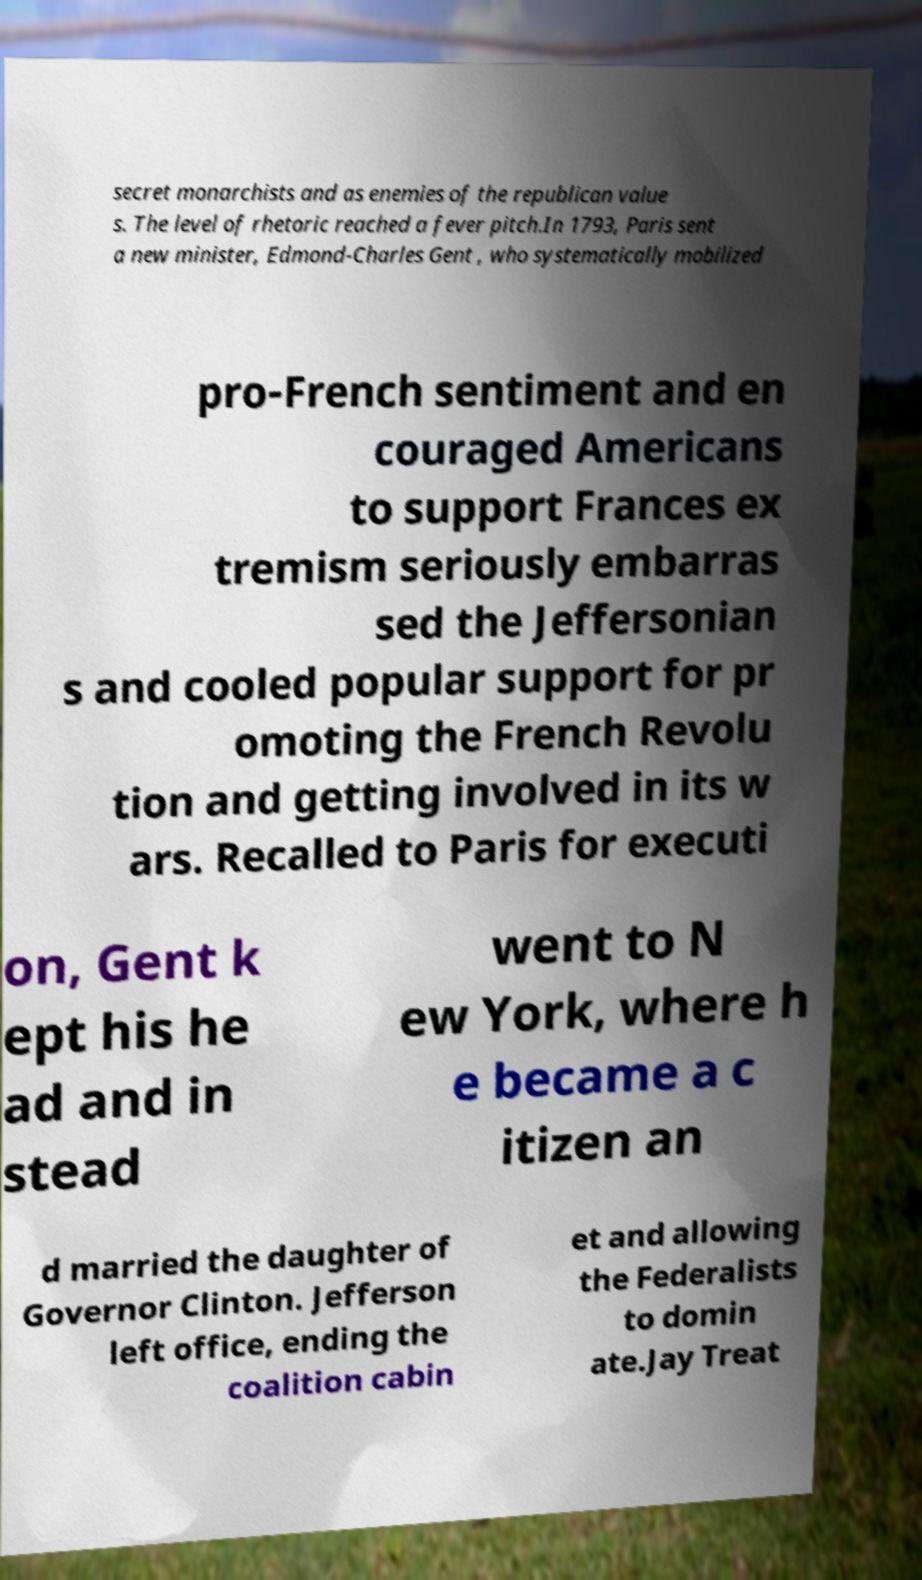There's text embedded in this image that I need extracted. Can you transcribe it verbatim? secret monarchists and as enemies of the republican value s. The level of rhetoric reached a fever pitch.In 1793, Paris sent a new minister, Edmond-Charles Gent , who systematically mobilized pro-French sentiment and en couraged Americans to support Frances ex tremism seriously embarras sed the Jeffersonian s and cooled popular support for pr omoting the French Revolu tion and getting involved in its w ars. Recalled to Paris for executi on, Gent k ept his he ad and in stead went to N ew York, where h e became a c itizen an d married the daughter of Governor Clinton. Jefferson left office, ending the coalition cabin et and allowing the Federalists to domin ate.Jay Treat 